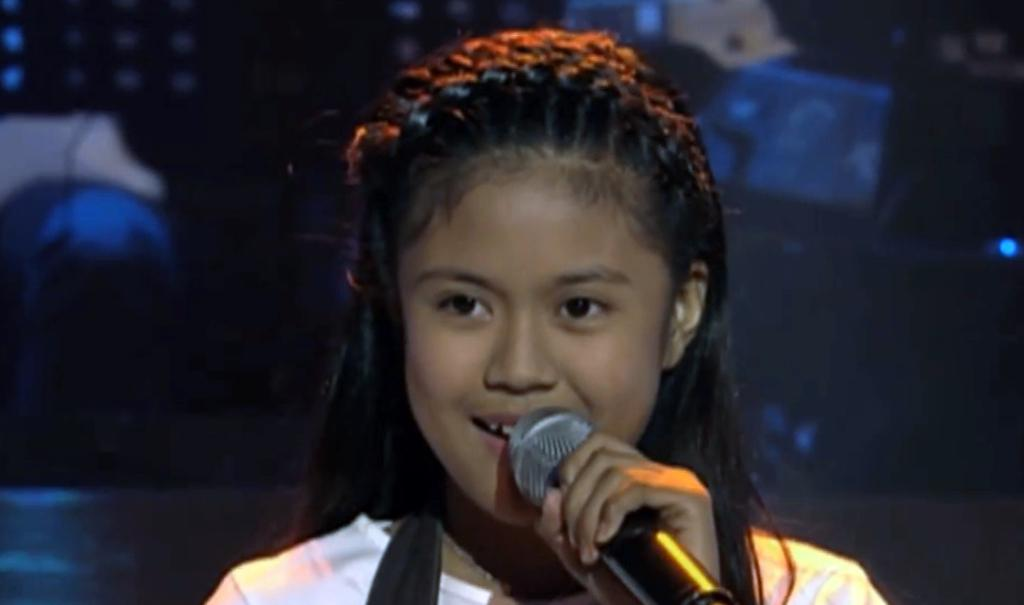Who is the main subject in the image? There is a girl in the image. What is the girl doing in the image? The girl is standing and singing a song. What is the girl holding in the image? The girl is holding a microphone. What is the girl wearing in the image? The girl is wearing a white dress. What can be said about the girl's hair in the image? The girl has long hair. Can you tell me how the girl is using the power of the river in the image? There is no river present in the image, and therefore no power of the river can be used by the girl. 